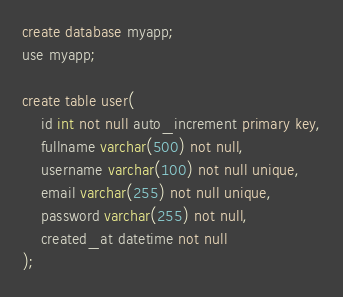<code> <loc_0><loc_0><loc_500><loc_500><_SQL_>create database myapp;
use myapp;

create table user(
	id int not null auto_increment primary key,
	fullname varchar(500) not null,
	username varchar(100) not null unique,
	email varchar(255) not null unique,
	password varchar(255) not null,
	created_at datetime not null
);</code> 